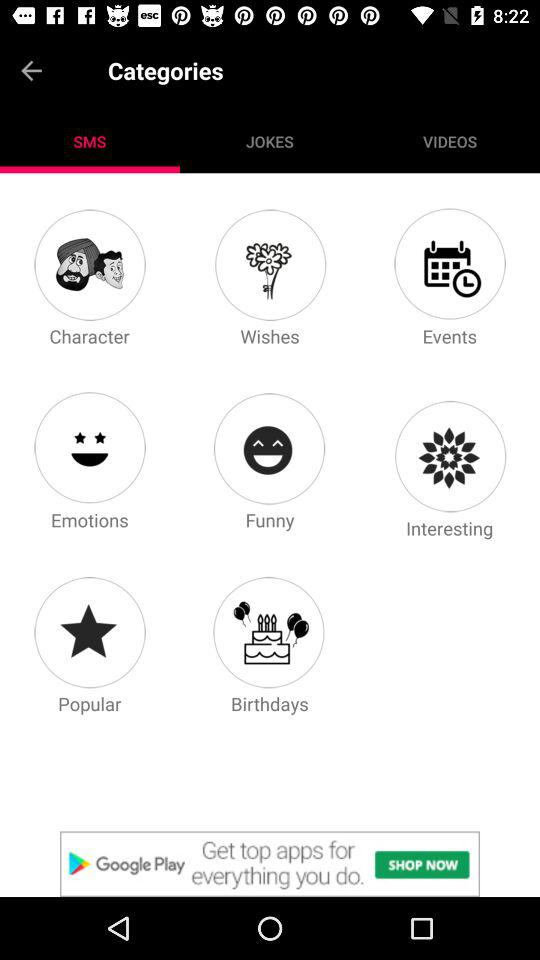Which option is selected? The selected option is "SMS". 